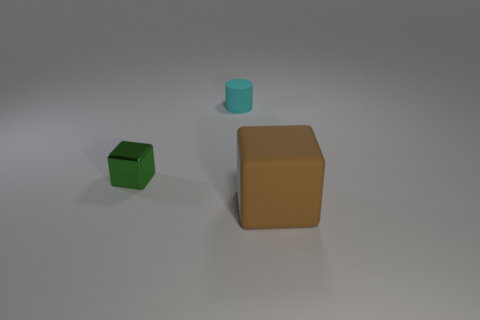The big brown object that is the same material as the cyan thing is what shape?
Your answer should be compact. Cube. How many green objects are either small rubber cylinders or large objects?
Offer a terse response. 0. There is a tiny object that is to the right of the cube on the left side of the rubber cube; is there a tiny green object right of it?
Your response must be concise. No. Is the number of blocks less than the number of large yellow objects?
Ensure brevity in your answer.  No. There is a small metallic thing on the left side of the cyan rubber cylinder; does it have the same shape as the cyan thing?
Ensure brevity in your answer.  No. Are any small purple rubber things visible?
Make the answer very short. No. What is the color of the cube behind the matte object to the right of the matte thing that is behind the big thing?
Offer a very short reply. Green. Is the number of small shiny cubes behind the tiny cylinder the same as the number of blocks that are to the left of the large brown cube?
Make the answer very short. No. What is the shape of the green metal object that is the same size as the matte cylinder?
Ensure brevity in your answer.  Cube. There is a matte thing that is in front of the small cyan cylinder; what is its shape?
Provide a short and direct response. Cube. 